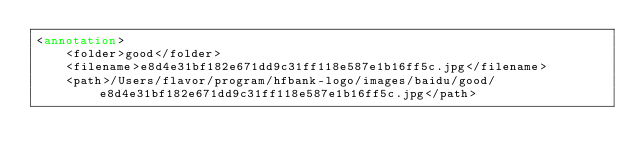Convert code to text. <code><loc_0><loc_0><loc_500><loc_500><_XML_><annotation>
	<folder>good</folder>
	<filename>e8d4e31bf182e671dd9c31ff118e587e1b16ff5c.jpg</filename>
	<path>/Users/flavor/program/hfbank-logo/images/baidu/good/e8d4e31bf182e671dd9c31ff118e587e1b16ff5c.jpg</path></code> 